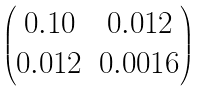<formula> <loc_0><loc_0><loc_500><loc_500>\begin{pmatrix} 0 . 1 0 & 0 . 0 1 2 \\ 0 . 0 1 2 & 0 . 0 0 1 6 \end{pmatrix}</formula> 